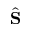<formula> <loc_0><loc_0><loc_500><loc_500>\hat { S }</formula> 